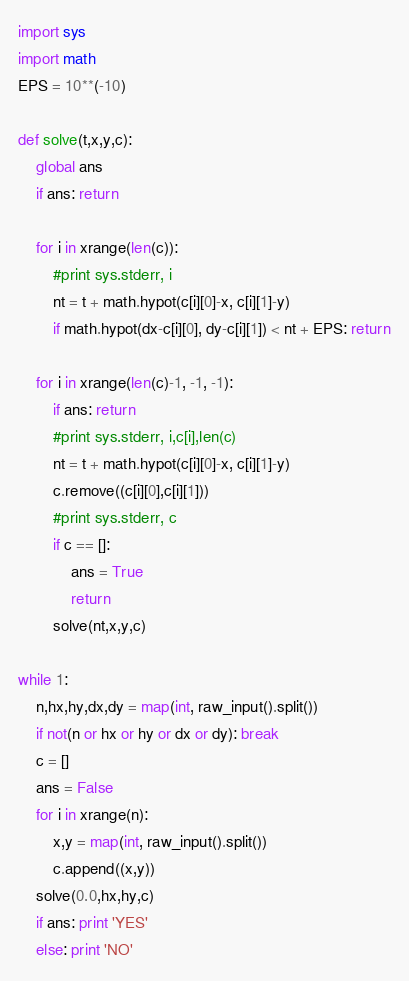<code> <loc_0><loc_0><loc_500><loc_500><_Python_>import sys
import math
EPS = 10**(-10)

def solve(t,x,y,c):
    global ans
    if ans: return

    for i in xrange(len(c)):
        #print sys.stderr, i
        nt = t + math.hypot(c[i][0]-x, c[i][1]-y)
        if math.hypot(dx-c[i][0], dy-c[i][1]) < nt + EPS: return

    for i in xrange(len(c)-1, -1, -1):
        if ans: return
        #print sys.stderr, i,c[i],len(c)
        nt = t + math.hypot(c[i][0]-x, c[i][1]-y)
        c.remove((c[i][0],c[i][1]))
        #print sys.stderr, c
        if c == []:
            ans = True
            return
        solve(nt,x,y,c)

while 1:
    n,hx,hy,dx,dy = map(int, raw_input().split())
    if not(n or hx or hy or dx or dy): break
    c = []
    ans = False
    for i in xrange(n):
        x,y = map(int, raw_input().split())
        c.append((x,y))
    solve(0.0,hx,hy,c)
    if ans: print 'YES'
    else: print 'NO'</code> 